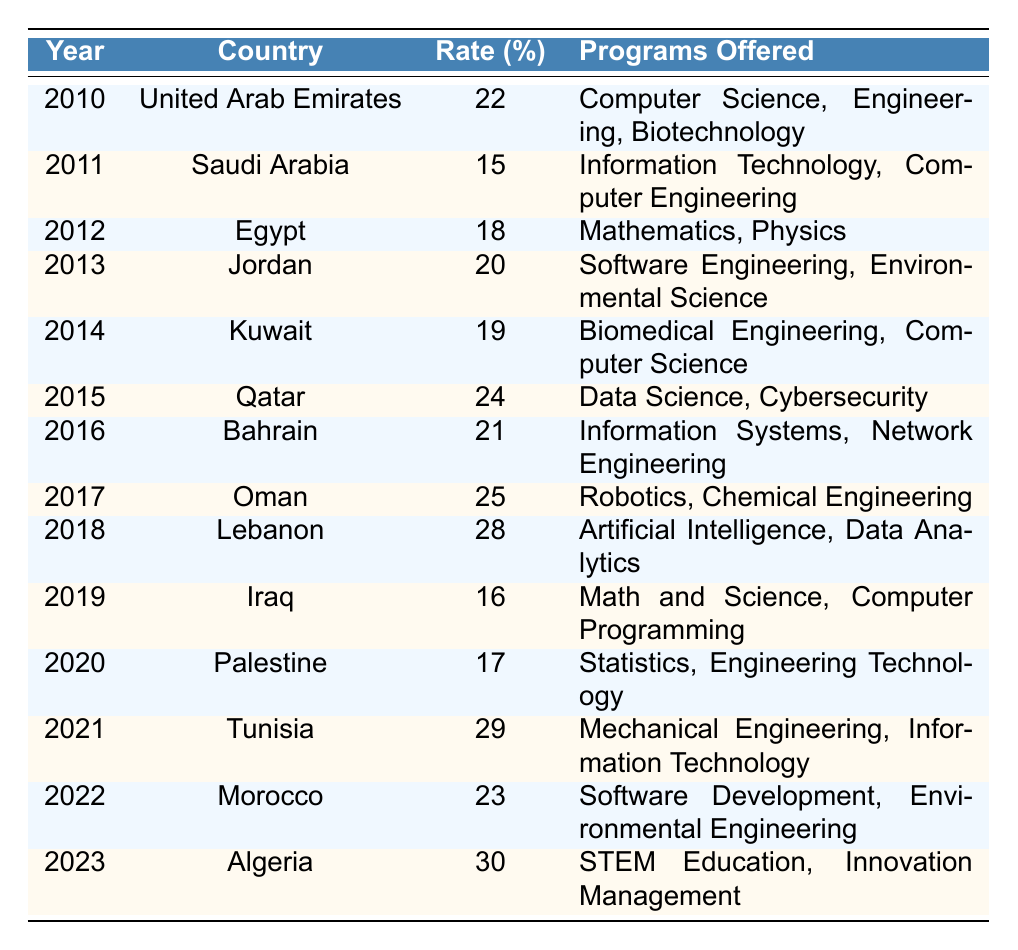What is the participation rate of young women in STEM in Saudi Arabia in 2011? From the table, we can directly find the row for Saudi Arabia in the year 2011, which shows a participation rate of 15%.
Answer: 15% Which country had the highest participation rate in 2023? Looking at the table, Algeria is the only entry for 2023, with a participation rate of 30%, and since it has no other competitors in that year, it is the highest for that year.
Answer: Algeria What is the difference in participation rates between Lebanon in 2018 and Egypt in 2012? The participation rate for Lebanon in 2018 is 28% and for Egypt in 2012 is 18%. To find the difference, subtract 18% from 28%, which results in 10%.
Answer: 10% Is the participation rate of young women in STEM in Bahrain higher than that in Jordan? From the table, Bahrain's participation rate in 2016 is 21% while Jordan's participation rate in 2013 is 20%. Since 21% is greater than 20%, the statement is true.
Answer: Yes What is the average participation rate of young women in STEM from 2010 to 2023? To find the average, we first sum the participation rates: 22 + 15 + 18 + 20 + 19 + 24 + 21 + 25 + 28 + 16 + 17 + 29 + 23 + 30 =  25. The total number of years is 14, so dividing the sum by 14 gives us an average participation rate of approximately 22.14%.
Answer: 22.14% What programs were offered in Qatar in 2015? In the row for Qatar under the year 2015, the table lists the offered programs as "Data Science" and "Cybersecurity." This information can be directly extracted from the table.
Answer: Data Science, Cybersecurity How many countries had a participation rate of 25% or higher by 2018? According to the table, the countries and their participation rates by 2018 are: UAE (22%), Saudi Arabia (15%), Egypt (18%), Jordan (20%), Kuwait (19%), Qatar (24%), Bahrain (21%), Oman (25%), and Lebanon (28%). The countries with a participation rate of 25% or higher are Oman (25%) and Lebanon (28%), making it a total of 2 countries.
Answer: 2 Did the participation rate of young women in STEM in Tunisia increase from 2020 to 2021? The participation rate in Palestine in 2020 is 17% while in Tunisia for 2021, it is 29%. A comparison shows that 29% is indeed greater than 17%, so yes, there was an increase.
Answer: Yes 